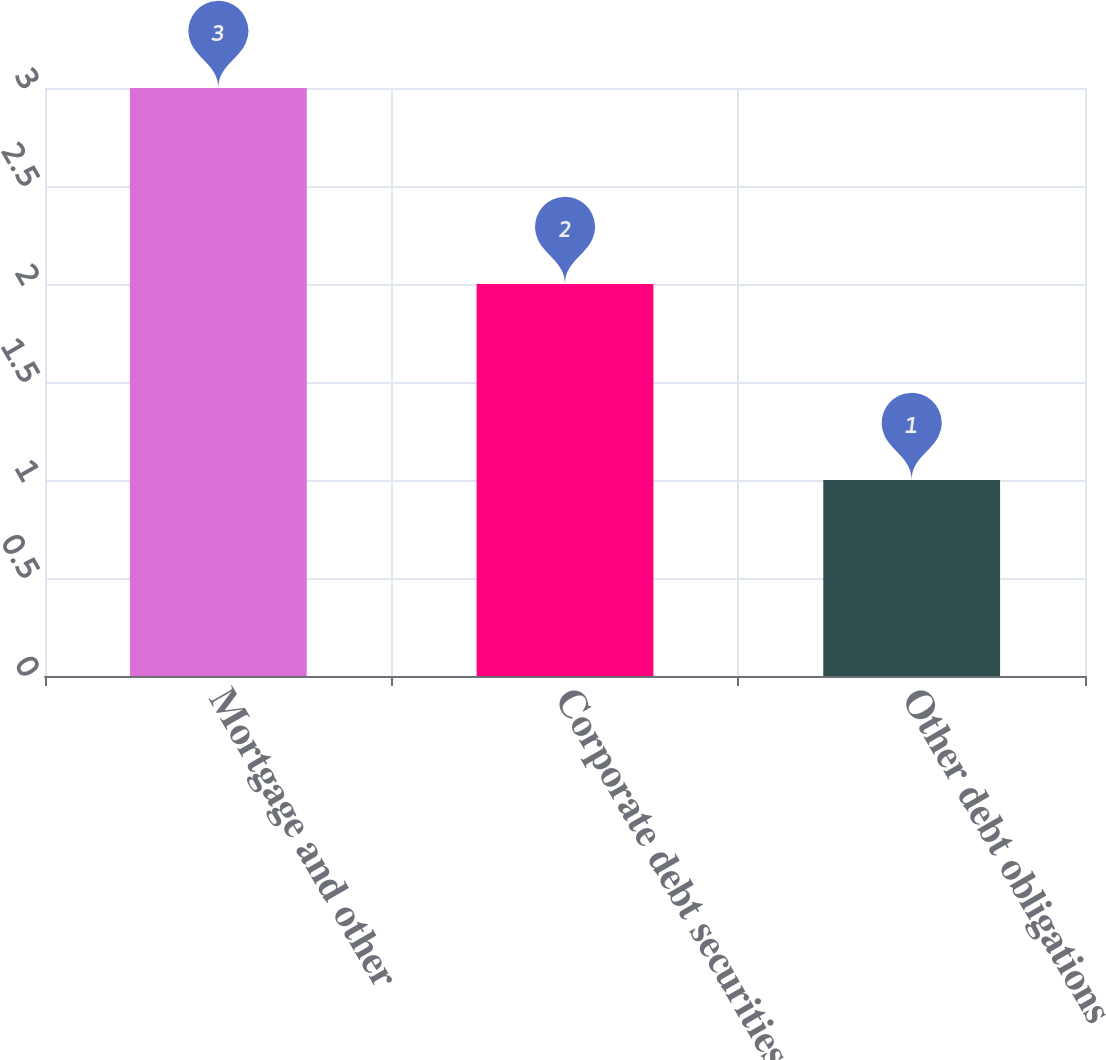Convert chart to OTSL. <chart><loc_0><loc_0><loc_500><loc_500><bar_chart><fcel>Mortgage and other<fcel>Corporate debt securities<fcel>Other debt obligations<nl><fcel>3<fcel>2<fcel>1<nl></chart> 